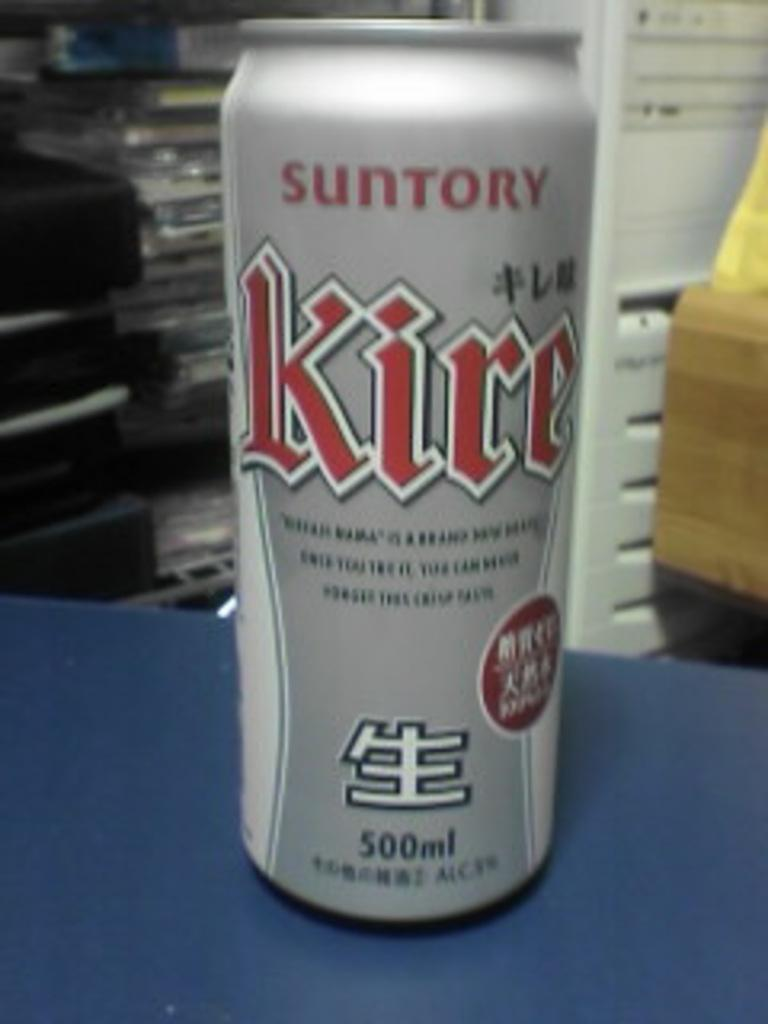<image>
Render a clear and concise summary of the photo. A can of Suntory Kire contains 500 ml of liquid. 